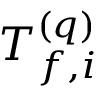Convert formula to latex. <formula><loc_0><loc_0><loc_500><loc_500>T _ { f , i } ^ { ( q ) }</formula> 